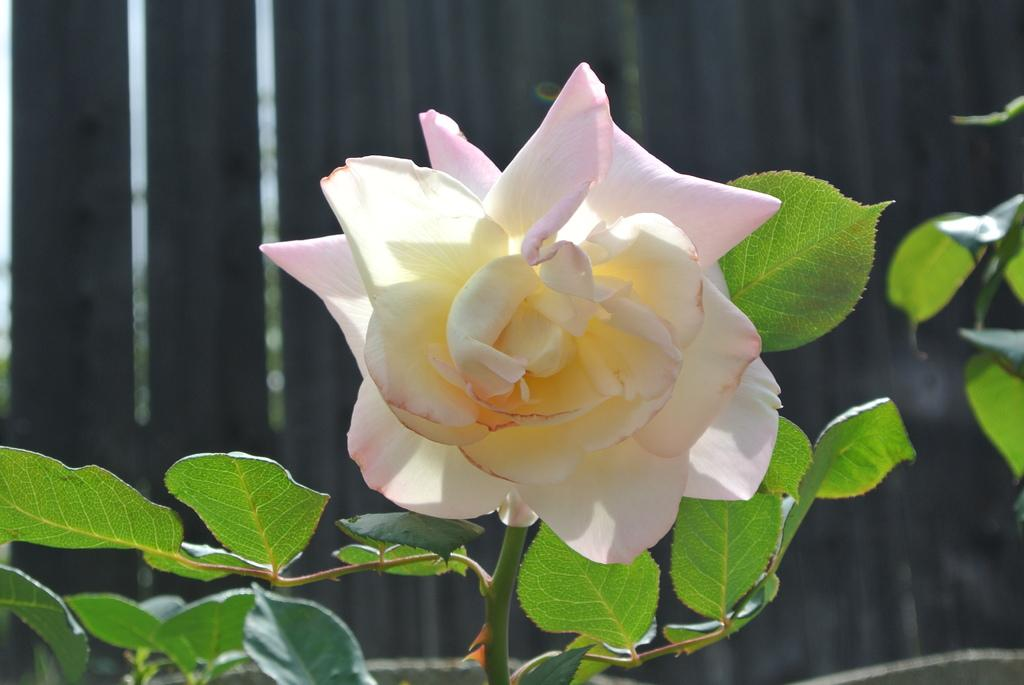What type of plant can be seen in the image? There is a plant with a flower in the image. Can you tell me how the amusement park is being used as a spy base in the image? There is no amusement park or reference to spying in the image; it features a plant with a flower. What type of wind turbine can be seen in the image? There is no wind turbine present in the image; it features a plant with a flower. 